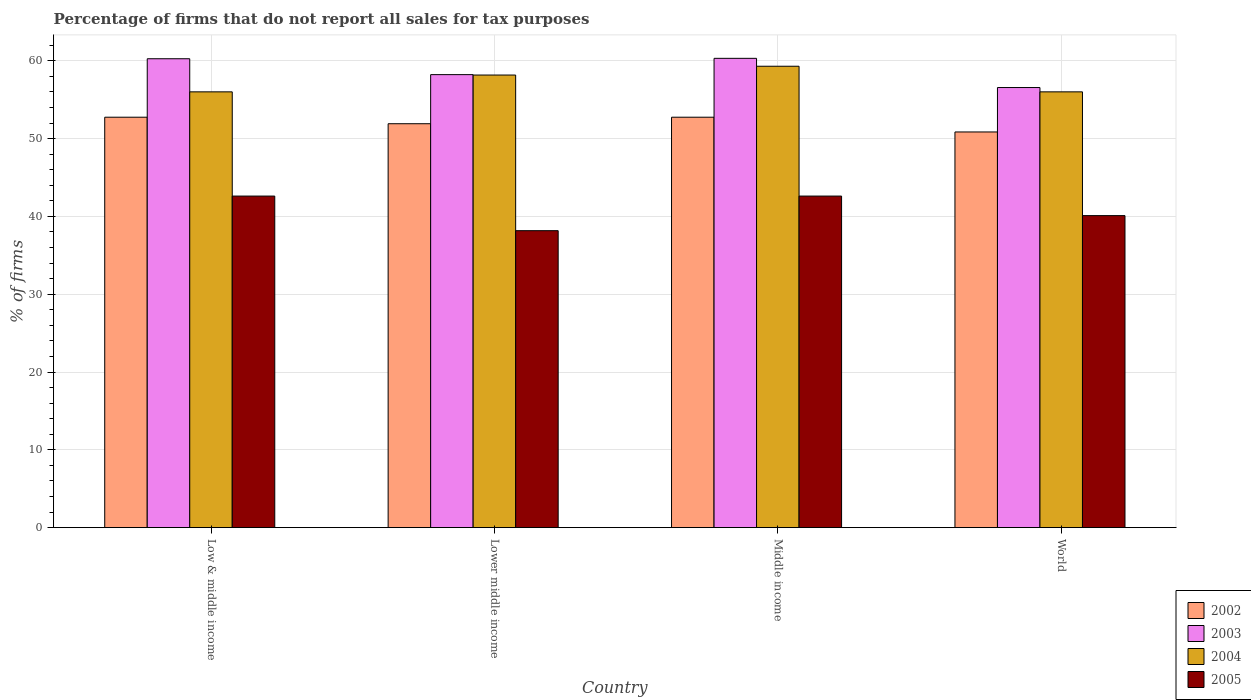How many different coloured bars are there?
Give a very brief answer. 4. How many groups of bars are there?
Ensure brevity in your answer.  4. Are the number of bars on each tick of the X-axis equal?
Provide a short and direct response. Yes. How many bars are there on the 1st tick from the right?
Your answer should be very brief. 4. In how many cases, is the number of bars for a given country not equal to the number of legend labels?
Your answer should be very brief. 0. What is the percentage of firms that do not report all sales for tax purposes in 2003 in World?
Provide a short and direct response. 56.56. Across all countries, what is the maximum percentage of firms that do not report all sales for tax purposes in 2003?
Keep it short and to the point. 60.31. Across all countries, what is the minimum percentage of firms that do not report all sales for tax purposes in 2004?
Your answer should be very brief. 56.01. In which country was the percentage of firms that do not report all sales for tax purposes in 2002 maximum?
Your response must be concise. Low & middle income. What is the total percentage of firms that do not report all sales for tax purposes in 2005 in the graph?
Ensure brevity in your answer.  163.48. What is the difference between the percentage of firms that do not report all sales for tax purposes in 2004 in Low & middle income and that in World?
Your answer should be compact. 0. What is the difference between the percentage of firms that do not report all sales for tax purposes in 2004 in Low & middle income and the percentage of firms that do not report all sales for tax purposes in 2003 in Lower middle income?
Offer a terse response. -2.21. What is the average percentage of firms that do not report all sales for tax purposes in 2003 per country?
Provide a short and direct response. 58.84. What is the difference between the percentage of firms that do not report all sales for tax purposes of/in 2005 and percentage of firms that do not report all sales for tax purposes of/in 2002 in Lower middle income?
Provide a succinct answer. -13.75. In how many countries, is the percentage of firms that do not report all sales for tax purposes in 2005 greater than 8 %?
Your response must be concise. 4. What is the ratio of the percentage of firms that do not report all sales for tax purposes in 2004 in Low & middle income to that in Lower middle income?
Keep it short and to the point. 0.96. Is the percentage of firms that do not report all sales for tax purposes in 2004 in Low & middle income less than that in Middle income?
Ensure brevity in your answer.  Yes. Is the difference between the percentage of firms that do not report all sales for tax purposes in 2005 in Low & middle income and Middle income greater than the difference between the percentage of firms that do not report all sales for tax purposes in 2002 in Low & middle income and Middle income?
Offer a very short reply. No. What is the difference between the highest and the second highest percentage of firms that do not report all sales for tax purposes in 2004?
Make the answer very short. -2.16. What is the difference between the highest and the lowest percentage of firms that do not report all sales for tax purposes in 2003?
Your response must be concise. 3.75. Is it the case that in every country, the sum of the percentage of firms that do not report all sales for tax purposes in 2005 and percentage of firms that do not report all sales for tax purposes in 2002 is greater than the sum of percentage of firms that do not report all sales for tax purposes in 2004 and percentage of firms that do not report all sales for tax purposes in 2003?
Make the answer very short. No. What does the 3rd bar from the right in World represents?
Provide a succinct answer. 2003. Is it the case that in every country, the sum of the percentage of firms that do not report all sales for tax purposes in 2002 and percentage of firms that do not report all sales for tax purposes in 2004 is greater than the percentage of firms that do not report all sales for tax purposes in 2005?
Your answer should be compact. Yes. How many countries are there in the graph?
Ensure brevity in your answer.  4. Are the values on the major ticks of Y-axis written in scientific E-notation?
Ensure brevity in your answer.  No. Does the graph contain any zero values?
Keep it short and to the point. No. What is the title of the graph?
Your answer should be very brief. Percentage of firms that do not report all sales for tax purposes. What is the label or title of the Y-axis?
Give a very brief answer. % of firms. What is the % of firms in 2002 in Low & middle income?
Provide a short and direct response. 52.75. What is the % of firms in 2003 in Low & middle income?
Offer a terse response. 60.26. What is the % of firms of 2004 in Low & middle income?
Give a very brief answer. 56.01. What is the % of firms in 2005 in Low & middle income?
Your response must be concise. 42.61. What is the % of firms of 2002 in Lower middle income?
Keep it short and to the point. 51.91. What is the % of firms in 2003 in Lower middle income?
Your answer should be compact. 58.22. What is the % of firms in 2004 in Lower middle income?
Provide a succinct answer. 58.16. What is the % of firms in 2005 in Lower middle income?
Your answer should be very brief. 38.16. What is the % of firms in 2002 in Middle income?
Offer a very short reply. 52.75. What is the % of firms of 2003 in Middle income?
Your response must be concise. 60.31. What is the % of firms of 2004 in Middle income?
Keep it short and to the point. 59.3. What is the % of firms in 2005 in Middle income?
Keep it short and to the point. 42.61. What is the % of firms in 2002 in World?
Your answer should be very brief. 50.85. What is the % of firms of 2003 in World?
Provide a succinct answer. 56.56. What is the % of firms of 2004 in World?
Ensure brevity in your answer.  56.01. What is the % of firms of 2005 in World?
Provide a short and direct response. 40.1. Across all countries, what is the maximum % of firms in 2002?
Offer a very short reply. 52.75. Across all countries, what is the maximum % of firms in 2003?
Give a very brief answer. 60.31. Across all countries, what is the maximum % of firms of 2004?
Your response must be concise. 59.3. Across all countries, what is the maximum % of firms in 2005?
Your answer should be compact. 42.61. Across all countries, what is the minimum % of firms of 2002?
Offer a terse response. 50.85. Across all countries, what is the minimum % of firms of 2003?
Your answer should be compact. 56.56. Across all countries, what is the minimum % of firms of 2004?
Your answer should be very brief. 56.01. Across all countries, what is the minimum % of firms of 2005?
Make the answer very short. 38.16. What is the total % of firms of 2002 in the graph?
Provide a short and direct response. 208.25. What is the total % of firms of 2003 in the graph?
Give a very brief answer. 235.35. What is the total % of firms of 2004 in the graph?
Keep it short and to the point. 229.47. What is the total % of firms in 2005 in the graph?
Your response must be concise. 163.48. What is the difference between the % of firms in 2002 in Low & middle income and that in Lower middle income?
Give a very brief answer. 0.84. What is the difference between the % of firms in 2003 in Low & middle income and that in Lower middle income?
Your answer should be compact. 2.04. What is the difference between the % of firms of 2004 in Low & middle income and that in Lower middle income?
Your answer should be compact. -2.16. What is the difference between the % of firms in 2005 in Low & middle income and that in Lower middle income?
Make the answer very short. 4.45. What is the difference between the % of firms in 2003 in Low & middle income and that in Middle income?
Offer a terse response. -0.05. What is the difference between the % of firms in 2004 in Low & middle income and that in Middle income?
Provide a succinct answer. -3.29. What is the difference between the % of firms in 2005 in Low & middle income and that in Middle income?
Ensure brevity in your answer.  0. What is the difference between the % of firms of 2002 in Low & middle income and that in World?
Offer a terse response. 1.89. What is the difference between the % of firms in 2005 in Low & middle income and that in World?
Your response must be concise. 2.51. What is the difference between the % of firms of 2002 in Lower middle income and that in Middle income?
Make the answer very short. -0.84. What is the difference between the % of firms in 2003 in Lower middle income and that in Middle income?
Provide a succinct answer. -2.09. What is the difference between the % of firms in 2004 in Lower middle income and that in Middle income?
Provide a short and direct response. -1.13. What is the difference between the % of firms of 2005 in Lower middle income and that in Middle income?
Ensure brevity in your answer.  -4.45. What is the difference between the % of firms in 2002 in Lower middle income and that in World?
Make the answer very short. 1.06. What is the difference between the % of firms in 2003 in Lower middle income and that in World?
Ensure brevity in your answer.  1.66. What is the difference between the % of firms in 2004 in Lower middle income and that in World?
Provide a short and direct response. 2.16. What is the difference between the % of firms of 2005 in Lower middle income and that in World?
Offer a terse response. -1.94. What is the difference between the % of firms in 2002 in Middle income and that in World?
Offer a very short reply. 1.89. What is the difference between the % of firms of 2003 in Middle income and that in World?
Give a very brief answer. 3.75. What is the difference between the % of firms in 2004 in Middle income and that in World?
Keep it short and to the point. 3.29. What is the difference between the % of firms of 2005 in Middle income and that in World?
Your response must be concise. 2.51. What is the difference between the % of firms in 2002 in Low & middle income and the % of firms in 2003 in Lower middle income?
Provide a succinct answer. -5.47. What is the difference between the % of firms in 2002 in Low & middle income and the % of firms in 2004 in Lower middle income?
Give a very brief answer. -5.42. What is the difference between the % of firms of 2002 in Low & middle income and the % of firms of 2005 in Lower middle income?
Ensure brevity in your answer.  14.58. What is the difference between the % of firms of 2003 in Low & middle income and the % of firms of 2004 in Lower middle income?
Your response must be concise. 2.1. What is the difference between the % of firms in 2003 in Low & middle income and the % of firms in 2005 in Lower middle income?
Your response must be concise. 22.1. What is the difference between the % of firms in 2004 in Low & middle income and the % of firms in 2005 in Lower middle income?
Provide a succinct answer. 17.84. What is the difference between the % of firms in 2002 in Low & middle income and the % of firms in 2003 in Middle income?
Keep it short and to the point. -7.57. What is the difference between the % of firms of 2002 in Low & middle income and the % of firms of 2004 in Middle income?
Your response must be concise. -6.55. What is the difference between the % of firms in 2002 in Low & middle income and the % of firms in 2005 in Middle income?
Keep it short and to the point. 10.13. What is the difference between the % of firms in 2003 in Low & middle income and the % of firms in 2005 in Middle income?
Keep it short and to the point. 17.65. What is the difference between the % of firms in 2004 in Low & middle income and the % of firms in 2005 in Middle income?
Offer a very short reply. 13.39. What is the difference between the % of firms in 2002 in Low & middle income and the % of firms in 2003 in World?
Your response must be concise. -3.81. What is the difference between the % of firms of 2002 in Low & middle income and the % of firms of 2004 in World?
Ensure brevity in your answer.  -3.26. What is the difference between the % of firms of 2002 in Low & middle income and the % of firms of 2005 in World?
Keep it short and to the point. 12.65. What is the difference between the % of firms in 2003 in Low & middle income and the % of firms in 2004 in World?
Provide a succinct answer. 4.25. What is the difference between the % of firms in 2003 in Low & middle income and the % of firms in 2005 in World?
Make the answer very short. 20.16. What is the difference between the % of firms of 2004 in Low & middle income and the % of firms of 2005 in World?
Give a very brief answer. 15.91. What is the difference between the % of firms of 2002 in Lower middle income and the % of firms of 2003 in Middle income?
Keep it short and to the point. -8.4. What is the difference between the % of firms in 2002 in Lower middle income and the % of firms in 2004 in Middle income?
Ensure brevity in your answer.  -7.39. What is the difference between the % of firms in 2002 in Lower middle income and the % of firms in 2005 in Middle income?
Provide a succinct answer. 9.3. What is the difference between the % of firms in 2003 in Lower middle income and the % of firms in 2004 in Middle income?
Provide a short and direct response. -1.08. What is the difference between the % of firms in 2003 in Lower middle income and the % of firms in 2005 in Middle income?
Provide a short and direct response. 15.61. What is the difference between the % of firms of 2004 in Lower middle income and the % of firms of 2005 in Middle income?
Your answer should be very brief. 15.55. What is the difference between the % of firms of 2002 in Lower middle income and the % of firms of 2003 in World?
Ensure brevity in your answer.  -4.65. What is the difference between the % of firms of 2002 in Lower middle income and the % of firms of 2004 in World?
Your answer should be compact. -4.1. What is the difference between the % of firms in 2002 in Lower middle income and the % of firms in 2005 in World?
Provide a succinct answer. 11.81. What is the difference between the % of firms of 2003 in Lower middle income and the % of firms of 2004 in World?
Give a very brief answer. 2.21. What is the difference between the % of firms of 2003 in Lower middle income and the % of firms of 2005 in World?
Give a very brief answer. 18.12. What is the difference between the % of firms of 2004 in Lower middle income and the % of firms of 2005 in World?
Your answer should be compact. 18.07. What is the difference between the % of firms in 2002 in Middle income and the % of firms in 2003 in World?
Your answer should be very brief. -3.81. What is the difference between the % of firms of 2002 in Middle income and the % of firms of 2004 in World?
Provide a short and direct response. -3.26. What is the difference between the % of firms of 2002 in Middle income and the % of firms of 2005 in World?
Make the answer very short. 12.65. What is the difference between the % of firms of 2003 in Middle income and the % of firms of 2004 in World?
Your answer should be very brief. 4.31. What is the difference between the % of firms of 2003 in Middle income and the % of firms of 2005 in World?
Offer a very short reply. 20.21. What is the difference between the % of firms of 2004 in Middle income and the % of firms of 2005 in World?
Ensure brevity in your answer.  19.2. What is the average % of firms of 2002 per country?
Offer a very short reply. 52.06. What is the average % of firms of 2003 per country?
Keep it short and to the point. 58.84. What is the average % of firms of 2004 per country?
Keep it short and to the point. 57.37. What is the average % of firms in 2005 per country?
Offer a terse response. 40.87. What is the difference between the % of firms in 2002 and % of firms in 2003 in Low & middle income?
Make the answer very short. -7.51. What is the difference between the % of firms in 2002 and % of firms in 2004 in Low & middle income?
Your response must be concise. -3.26. What is the difference between the % of firms in 2002 and % of firms in 2005 in Low & middle income?
Make the answer very short. 10.13. What is the difference between the % of firms of 2003 and % of firms of 2004 in Low & middle income?
Ensure brevity in your answer.  4.25. What is the difference between the % of firms in 2003 and % of firms in 2005 in Low & middle income?
Give a very brief answer. 17.65. What is the difference between the % of firms in 2004 and % of firms in 2005 in Low & middle income?
Your answer should be compact. 13.39. What is the difference between the % of firms of 2002 and % of firms of 2003 in Lower middle income?
Make the answer very short. -6.31. What is the difference between the % of firms of 2002 and % of firms of 2004 in Lower middle income?
Your answer should be compact. -6.26. What is the difference between the % of firms of 2002 and % of firms of 2005 in Lower middle income?
Offer a terse response. 13.75. What is the difference between the % of firms in 2003 and % of firms in 2004 in Lower middle income?
Ensure brevity in your answer.  0.05. What is the difference between the % of firms in 2003 and % of firms in 2005 in Lower middle income?
Your answer should be compact. 20.06. What is the difference between the % of firms of 2004 and % of firms of 2005 in Lower middle income?
Ensure brevity in your answer.  20. What is the difference between the % of firms in 2002 and % of firms in 2003 in Middle income?
Give a very brief answer. -7.57. What is the difference between the % of firms of 2002 and % of firms of 2004 in Middle income?
Your answer should be very brief. -6.55. What is the difference between the % of firms of 2002 and % of firms of 2005 in Middle income?
Provide a short and direct response. 10.13. What is the difference between the % of firms of 2003 and % of firms of 2004 in Middle income?
Your answer should be compact. 1.02. What is the difference between the % of firms of 2003 and % of firms of 2005 in Middle income?
Keep it short and to the point. 17.7. What is the difference between the % of firms in 2004 and % of firms in 2005 in Middle income?
Your answer should be compact. 16.69. What is the difference between the % of firms in 2002 and % of firms in 2003 in World?
Make the answer very short. -5.71. What is the difference between the % of firms of 2002 and % of firms of 2004 in World?
Provide a succinct answer. -5.15. What is the difference between the % of firms in 2002 and % of firms in 2005 in World?
Give a very brief answer. 10.75. What is the difference between the % of firms in 2003 and % of firms in 2004 in World?
Your answer should be compact. 0.56. What is the difference between the % of firms of 2003 and % of firms of 2005 in World?
Keep it short and to the point. 16.46. What is the difference between the % of firms of 2004 and % of firms of 2005 in World?
Provide a short and direct response. 15.91. What is the ratio of the % of firms in 2002 in Low & middle income to that in Lower middle income?
Keep it short and to the point. 1.02. What is the ratio of the % of firms in 2003 in Low & middle income to that in Lower middle income?
Offer a very short reply. 1.04. What is the ratio of the % of firms in 2004 in Low & middle income to that in Lower middle income?
Offer a terse response. 0.96. What is the ratio of the % of firms of 2005 in Low & middle income to that in Lower middle income?
Offer a terse response. 1.12. What is the ratio of the % of firms of 2003 in Low & middle income to that in Middle income?
Offer a very short reply. 1. What is the ratio of the % of firms of 2004 in Low & middle income to that in Middle income?
Keep it short and to the point. 0.94. What is the ratio of the % of firms in 2005 in Low & middle income to that in Middle income?
Ensure brevity in your answer.  1. What is the ratio of the % of firms of 2002 in Low & middle income to that in World?
Provide a short and direct response. 1.04. What is the ratio of the % of firms of 2003 in Low & middle income to that in World?
Give a very brief answer. 1.07. What is the ratio of the % of firms in 2005 in Low & middle income to that in World?
Your answer should be compact. 1.06. What is the ratio of the % of firms of 2002 in Lower middle income to that in Middle income?
Give a very brief answer. 0.98. What is the ratio of the % of firms in 2003 in Lower middle income to that in Middle income?
Offer a terse response. 0.97. What is the ratio of the % of firms in 2004 in Lower middle income to that in Middle income?
Offer a very short reply. 0.98. What is the ratio of the % of firms of 2005 in Lower middle income to that in Middle income?
Your response must be concise. 0.9. What is the ratio of the % of firms of 2002 in Lower middle income to that in World?
Ensure brevity in your answer.  1.02. What is the ratio of the % of firms in 2003 in Lower middle income to that in World?
Offer a terse response. 1.03. What is the ratio of the % of firms in 2004 in Lower middle income to that in World?
Offer a terse response. 1.04. What is the ratio of the % of firms of 2005 in Lower middle income to that in World?
Give a very brief answer. 0.95. What is the ratio of the % of firms of 2002 in Middle income to that in World?
Your answer should be very brief. 1.04. What is the ratio of the % of firms of 2003 in Middle income to that in World?
Make the answer very short. 1.07. What is the ratio of the % of firms of 2004 in Middle income to that in World?
Your answer should be very brief. 1.06. What is the ratio of the % of firms of 2005 in Middle income to that in World?
Provide a short and direct response. 1.06. What is the difference between the highest and the second highest % of firms in 2003?
Offer a very short reply. 0.05. What is the difference between the highest and the second highest % of firms in 2004?
Ensure brevity in your answer.  1.13. What is the difference between the highest and the second highest % of firms in 2005?
Offer a very short reply. 0. What is the difference between the highest and the lowest % of firms of 2002?
Give a very brief answer. 1.89. What is the difference between the highest and the lowest % of firms in 2003?
Your response must be concise. 3.75. What is the difference between the highest and the lowest % of firms of 2004?
Your answer should be compact. 3.29. What is the difference between the highest and the lowest % of firms in 2005?
Ensure brevity in your answer.  4.45. 